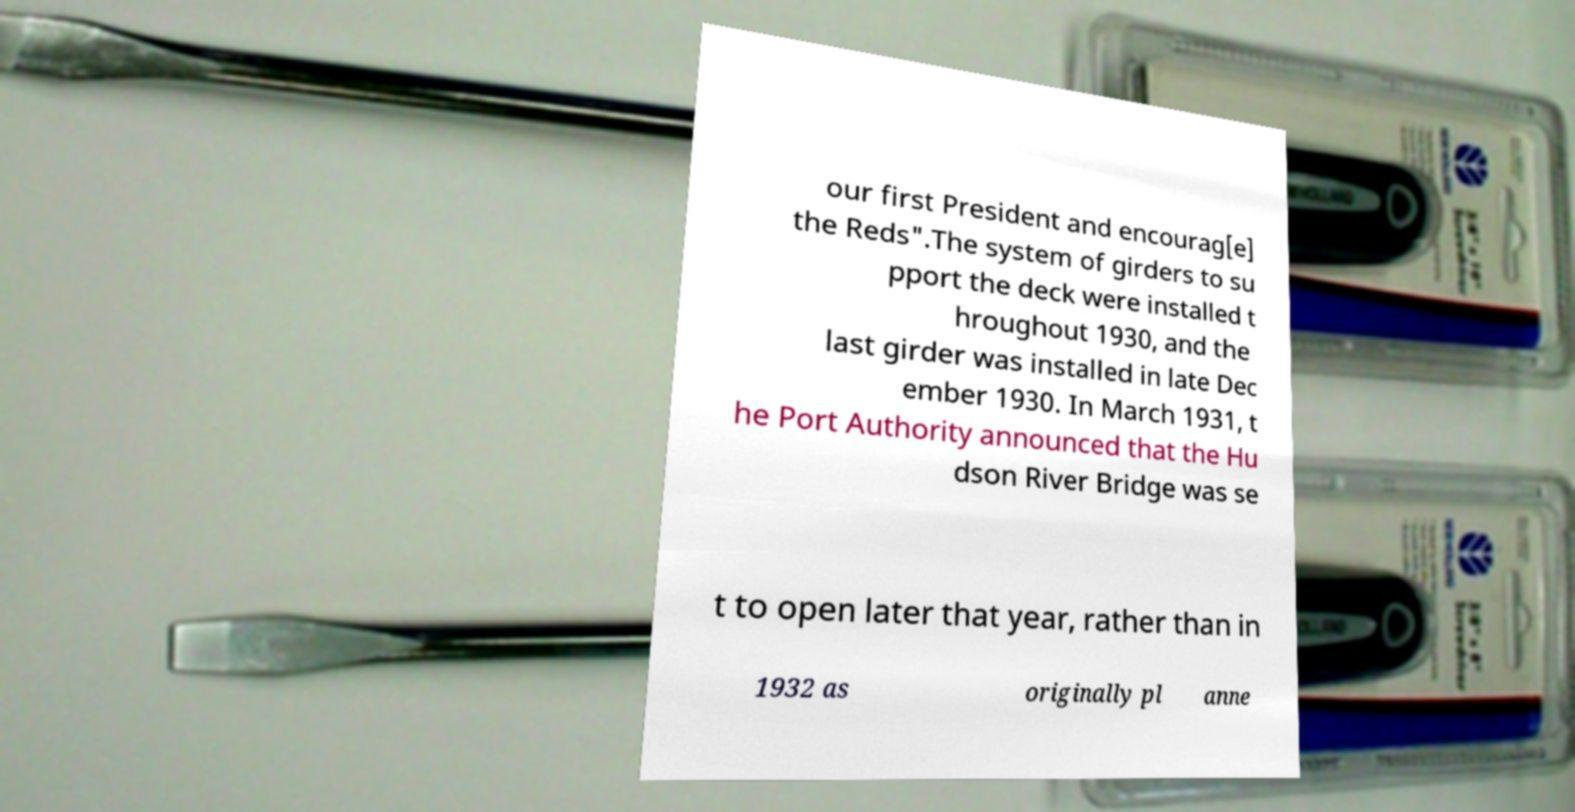What messages or text are displayed in this image? I need them in a readable, typed format. our first President and encourag[e] the Reds".The system of girders to su pport the deck were installed t hroughout 1930, and the last girder was installed in late Dec ember 1930. In March 1931, t he Port Authority announced that the Hu dson River Bridge was se t to open later that year, rather than in 1932 as originally pl anne 